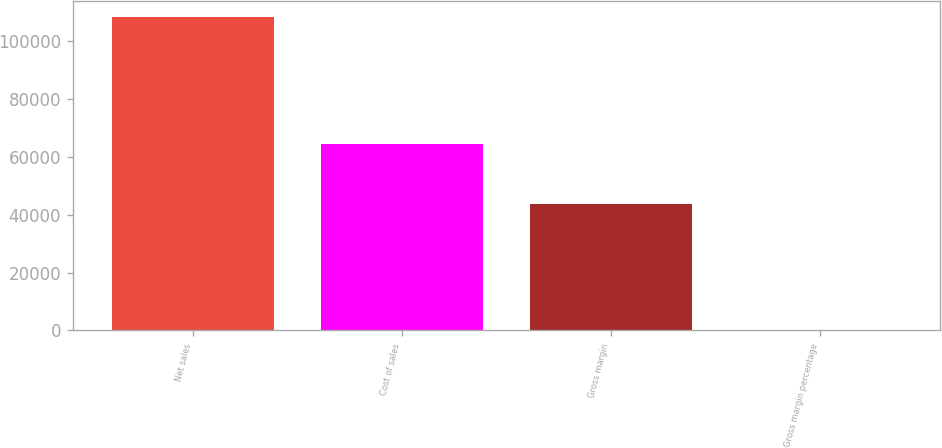<chart> <loc_0><loc_0><loc_500><loc_500><bar_chart><fcel>Net sales<fcel>Cost of sales<fcel>Gross margin<fcel>Gross margin percentage<nl><fcel>108249<fcel>64431<fcel>43818<fcel>40.5<nl></chart> 